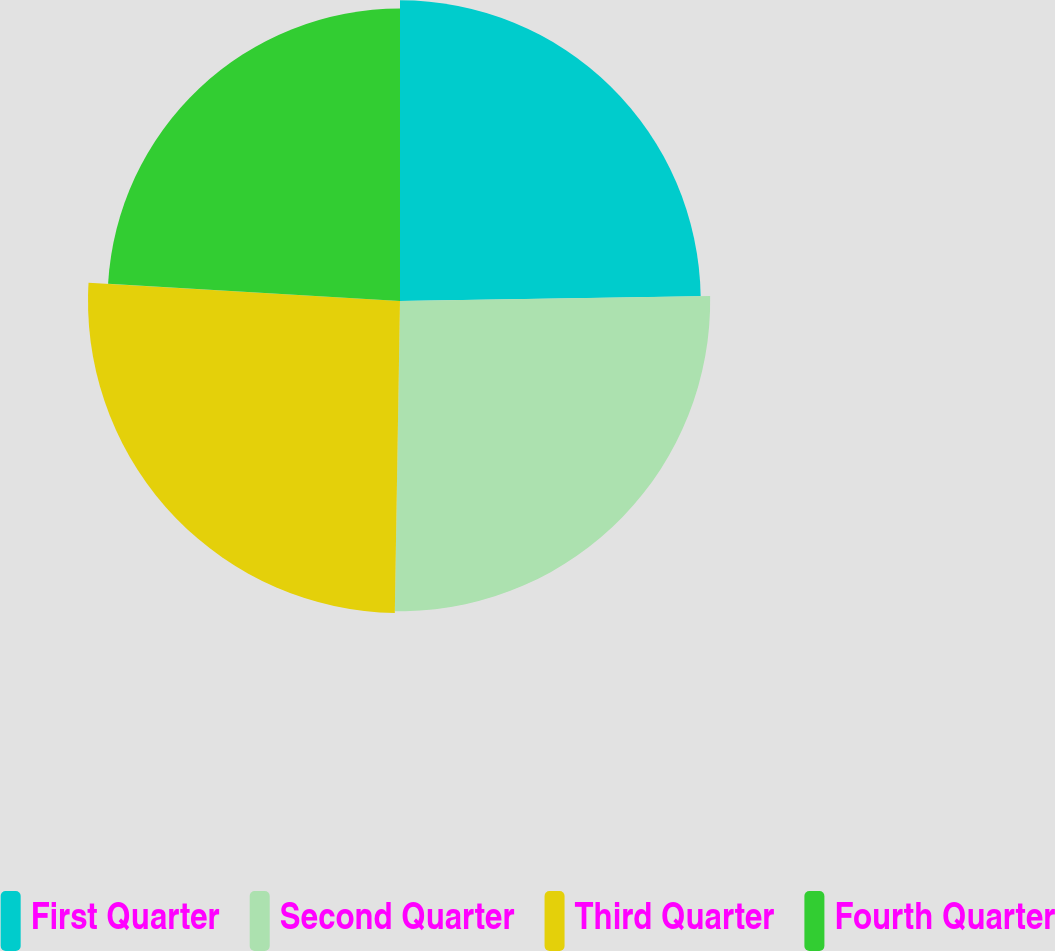<chart> <loc_0><loc_0><loc_500><loc_500><pie_chart><fcel>First Quarter<fcel>Second Quarter<fcel>Third Quarter<fcel>Fourth Quarter<nl><fcel>24.74%<fcel>25.52%<fcel>25.67%<fcel>24.06%<nl></chart> 